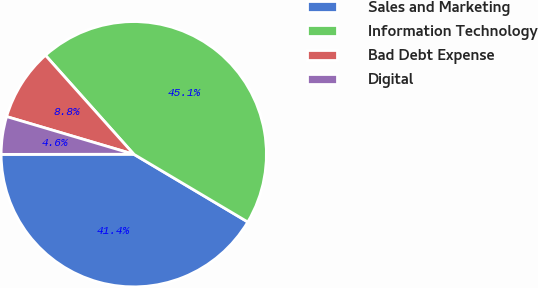Convert chart. <chart><loc_0><loc_0><loc_500><loc_500><pie_chart><fcel>Sales and Marketing<fcel>Information Technology<fcel>Bad Debt Expense<fcel>Digital<nl><fcel>41.45%<fcel>45.14%<fcel>8.82%<fcel>4.6%<nl></chart> 